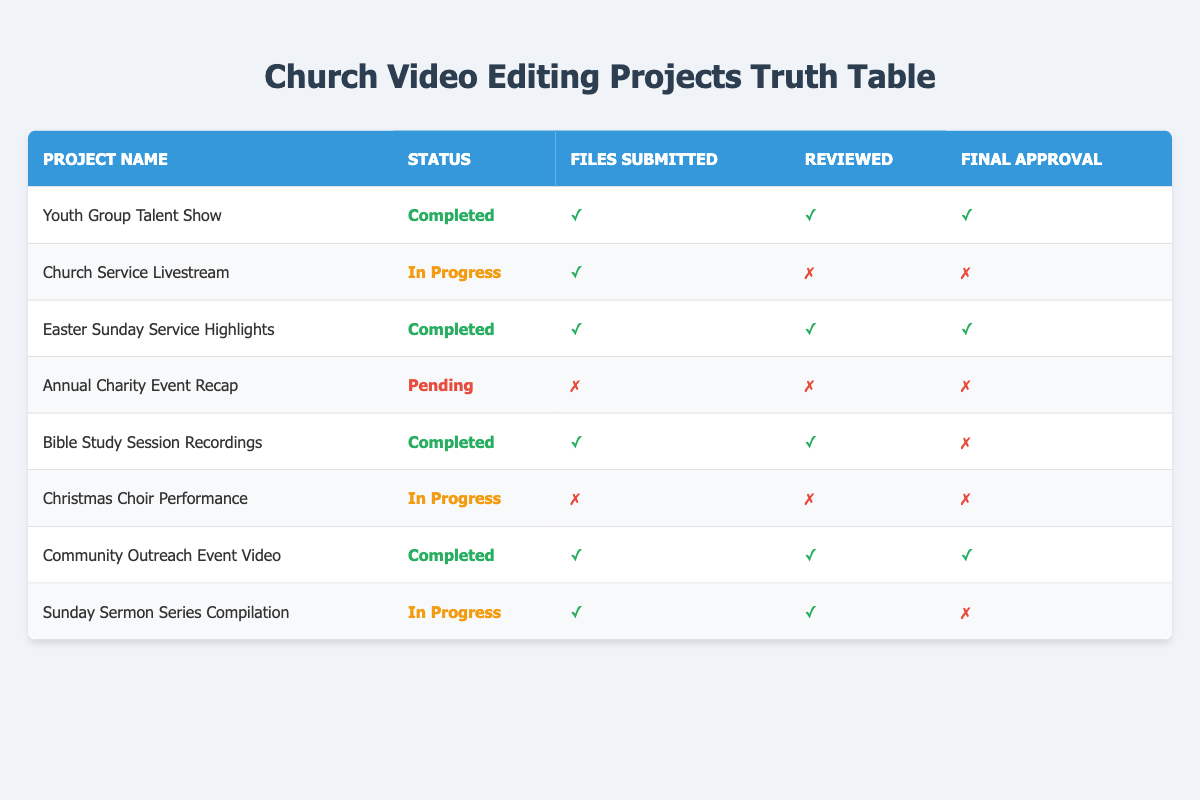What is the status of the "Youth Group Talent Show" project? The status of the "Youth Group Talent Show" project can be found in the "Status" column for that row, which indicates that the project is "Completed."
Answer: Completed How many projects are currently in progress? To find the number of projects in progress, we check the "Status" column and count the entries that say "In Progress." There are three such entries: "Church Service Livestream," "Christmas Choir Performance," and "Sunday Sermon Series Compilation."
Answer: 3 Did the "Bible Study Session Recordings" project receive final approval? By looking at the "Final Approval" column for the "Bible Study Session Recordings" project, it shows a cross (✗), indicating that it did not receive final approval.
Answer: No Which project has files submitted but is still pending review? We look for a project with "Files Submitted" as true (checked) and "Reviewed" as false (cross) in the table. The "Church Service Livestream" project is the only one meeting these conditions.
Answer: Church Service Livestream What percentage of projects are completed? There are a total of eight projects listed. Out of these, five are marked as completed. To find the percentage, we calculate (5 completed projects / 8 total projects) * 100, which equals 62.5%.
Answer: 62.5% Is there any project that is both completed and did not receive final approval? We search for completed projects and check if any of them show "Final Approval" as false (cross). The "Bible Study Session Recordings" project fits this description, as it is completed but has no final approval.
Answer: Yes What is the status of the project with the least progress? The project with the least progress is the "Annual Charity Event Recap," which is marked as "Pending." This is the only project that has not submitted any files and has neither been reviewed nor received final approval.
Answer: Pending How many total files have been submitted across all completed projects? We check the "Files Submitted" column for each completed project: "Youth Group Talent Show," "Easter Sunday Service Highlights," "Bible Study Session Recordings," and "Community Outreach Event Video." All these projects have files submitted (true). Therefore, the total is 4 projects with files submitted.
Answer: 4 How many projects are still awaiting review? We look for projects that have been submitted (files submitted as true) but have not been reviewed (reviewed as false). The "Church Service Livestream" qualifies under this condition, indicating there is 1 project still awaiting review.
Answer: 1 